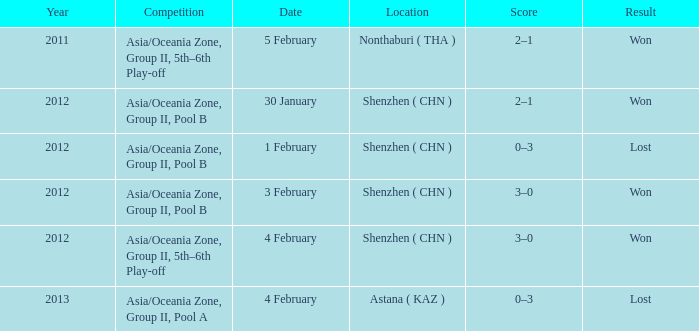What is the sum of the year for 5 february? 2011.0. 